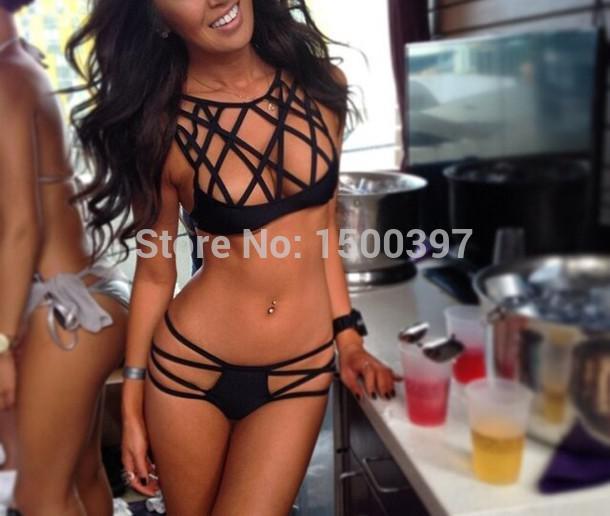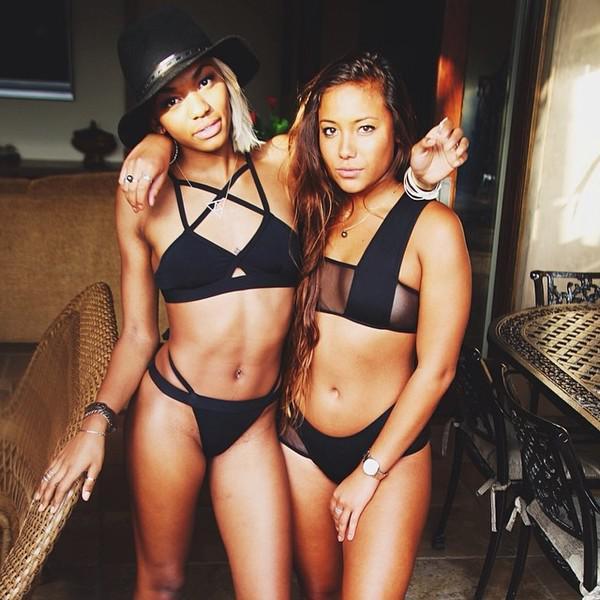The first image is the image on the left, the second image is the image on the right. Analyze the images presented: Is the assertion "There is a woman wearing a hat." valid? Answer yes or no. Yes. 